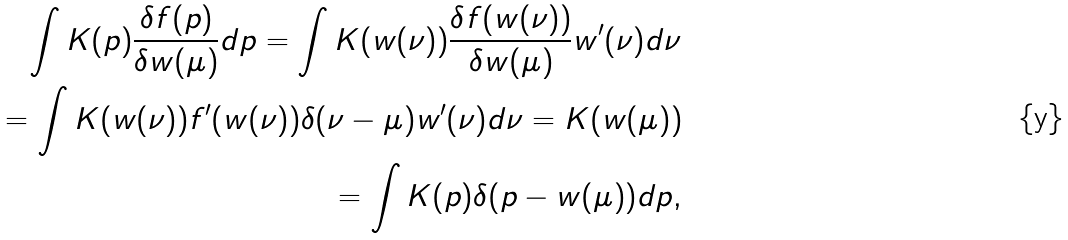<formula> <loc_0><loc_0><loc_500><loc_500>\int K ( p ) \frac { \delta f ( p ) } { \delta w ( \mu ) } d p = \int K ( w ( \nu ) ) \frac { \delta f ( w ( \nu ) ) } { \delta w ( \mu ) } w ^ { \prime } ( \nu ) d \nu \\ = \int K ( w ( \nu ) ) f ^ { \prime } ( w ( \nu ) ) \delta ( \nu - \mu ) w ^ { \prime } ( \nu ) d \nu = K ( w ( \mu ) ) \\ = \int K ( p ) \delta ( p - w ( \mu ) ) d p ,</formula> 